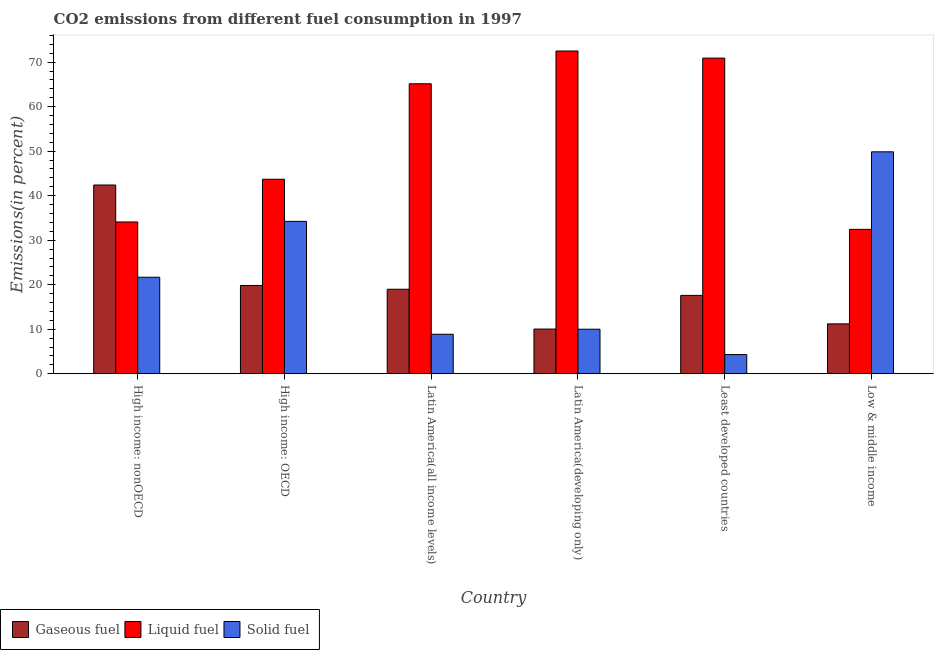How many groups of bars are there?
Provide a short and direct response. 6. How many bars are there on the 4th tick from the left?
Give a very brief answer. 3. What is the label of the 1st group of bars from the left?
Provide a short and direct response. High income: nonOECD. In how many cases, is the number of bars for a given country not equal to the number of legend labels?
Your response must be concise. 0. What is the percentage of gaseous fuel emission in Latin America(developing only)?
Your answer should be very brief. 10.04. Across all countries, what is the maximum percentage of solid fuel emission?
Provide a succinct answer. 49.85. Across all countries, what is the minimum percentage of liquid fuel emission?
Give a very brief answer. 32.44. What is the total percentage of gaseous fuel emission in the graph?
Give a very brief answer. 120.05. What is the difference between the percentage of solid fuel emission in High income: OECD and that in Latin America(developing only)?
Give a very brief answer. 24.23. What is the difference between the percentage of gaseous fuel emission in Latin America(all income levels) and the percentage of liquid fuel emission in Latin America(developing only)?
Your answer should be very brief. -53.52. What is the average percentage of liquid fuel emission per country?
Your answer should be compact. 53.13. What is the difference between the percentage of solid fuel emission and percentage of liquid fuel emission in Latin America(all income levels)?
Provide a succinct answer. -56.27. In how many countries, is the percentage of liquid fuel emission greater than 68 %?
Provide a succinct answer. 2. What is the ratio of the percentage of solid fuel emission in Latin America(all income levels) to that in Low & middle income?
Offer a very short reply. 0.18. Is the percentage of liquid fuel emission in High income: OECD less than that in Low & middle income?
Ensure brevity in your answer.  No. What is the difference between the highest and the second highest percentage of solid fuel emission?
Offer a terse response. 15.63. What is the difference between the highest and the lowest percentage of liquid fuel emission?
Your answer should be compact. 40.07. Is the sum of the percentage of solid fuel emission in High income: OECD and High income: nonOECD greater than the maximum percentage of liquid fuel emission across all countries?
Offer a very short reply. No. What does the 3rd bar from the left in Latin America(developing only) represents?
Ensure brevity in your answer.  Solid fuel. What does the 1st bar from the right in High income: nonOECD represents?
Keep it short and to the point. Solid fuel. Are all the bars in the graph horizontal?
Your response must be concise. No. What is the difference between two consecutive major ticks on the Y-axis?
Offer a terse response. 10. Are the values on the major ticks of Y-axis written in scientific E-notation?
Offer a terse response. No. Does the graph contain any zero values?
Offer a terse response. No. Does the graph contain grids?
Offer a very short reply. No. Where does the legend appear in the graph?
Give a very brief answer. Bottom left. What is the title of the graph?
Your answer should be compact. CO2 emissions from different fuel consumption in 1997. What is the label or title of the Y-axis?
Make the answer very short. Emissions(in percent). What is the Emissions(in percent) in Gaseous fuel in High income: nonOECD?
Make the answer very short. 42.4. What is the Emissions(in percent) in Liquid fuel in High income: nonOECD?
Make the answer very short. 34.1. What is the Emissions(in percent) in Solid fuel in High income: nonOECD?
Your answer should be compact. 21.68. What is the Emissions(in percent) in Gaseous fuel in High income: OECD?
Ensure brevity in your answer.  19.83. What is the Emissions(in percent) in Liquid fuel in High income: OECD?
Your response must be concise. 43.7. What is the Emissions(in percent) of Solid fuel in High income: OECD?
Your answer should be very brief. 34.23. What is the Emissions(in percent) in Gaseous fuel in Latin America(all income levels)?
Offer a terse response. 18.98. What is the Emissions(in percent) of Liquid fuel in Latin America(all income levels)?
Provide a succinct answer. 65.14. What is the Emissions(in percent) in Solid fuel in Latin America(all income levels)?
Offer a very short reply. 8.87. What is the Emissions(in percent) in Gaseous fuel in Latin America(developing only)?
Keep it short and to the point. 10.04. What is the Emissions(in percent) of Liquid fuel in Latin America(developing only)?
Your answer should be very brief. 72.5. What is the Emissions(in percent) of Solid fuel in Latin America(developing only)?
Your response must be concise. 10. What is the Emissions(in percent) of Gaseous fuel in Least developed countries?
Ensure brevity in your answer.  17.6. What is the Emissions(in percent) in Liquid fuel in Least developed countries?
Ensure brevity in your answer.  70.91. What is the Emissions(in percent) in Solid fuel in Least developed countries?
Provide a short and direct response. 4.31. What is the Emissions(in percent) in Gaseous fuel in Low & middle income?
Offer a very short reply. 11.2. What is the Emissions(in percent) in Liquid fuel in Low & middle income?
Make the answer very short. 32.44. What is the Emissions(in percent) of Solid fuel in Low & middle income?
Give a very brief answer. 49.85. Across all countries, what is the maximum Emissions(in percent) in Gaseous fuel?
Your answer should be compact. 42.4. Across all countries, what is the maximum Emissions(in percent) of Liquid fuel?
Give a very brief answer. 72.5. Across all countries, what is the maximum Emissions(in percent) in Solid fuel?
Keep it short and to the point. 49.85. Across all countries, what is the minimum Emissions(in percent) in Gaseous fuel?
Offer a terse response. 10.04. Across all countries, what is the minimum Emissions(in percent) in Liquid fuel?
Your response must be concise. 32.44. Across all countries, what is the minimum Emissions(in percent) of Solid fuel?
Give a very brief answer. 4.31. What is the total Emissions(in percent) in Gaseous fuel in the graph?
Your answer should be very brief. 120.05. What is the total Emissions(in percent) in Liquid fuel in the graph?
Offer a very short reply. 318.78. What is the total Emissions(in percent) in Solid fuel in the graph?
Ensure brevity in your answer.  128.95. What is the difference between the Emissions(in percent) in Gaseous fuel in High income: nonOECD and that in High income: OECD?
Provide a short and direct response. 22.57. What is the difference between the Emissions(in percent) of Liquid fuel in High income: nonOECD and that in High income: OECD?
Your answer should be very brief. -9.6. What is the difference between the Emissions(in percent) in Solid fuel in High income: nonOECD and that in High income: OECD?
Your answer should be compact. -12.55. What is the difference between the Emissions(in percent) in Gaseous fuel in High income: nonOECD and that in Latin America(all income levels)?
Your response must be concise. 23.42. What is the difference between the Emissions(in percent) in Liquid fuel in High income: nonOECD and that in Latin America(all income levels)?
Give a very brief answer. -31.05. What is the difference between the Emissions(in percent) of Solid fuel in High income: nonOECD and that in Latin America(all income levels)?
Keep it short and to the point. 12.81. What is the difference between the Emissions(in percent) of Gaseous fuel in High income: nonOECD and that in Latin America(developing only)?
Your answer should be compact. 32.36. What is the difference between the Emissions(in percent) of Liquid fuel in High income: nonOECD and that in Latin America(developing only)?
Make the answer very short. -38.41. What is the difference between the Emissions(in percent) of Solid fuel in High income: nonOECD and that in Latin America(developing only)?
Keep it short and to the point. 11.68. What is the difference between the Emissions(in percent) of Gaseous fuel in High income: nonOECD and that in Least developed countries?
Ensure brevity in your answer.  24.79. What is the difference between the Emissions(in percent) of Liquid fuel in High income: nonOECD and that in Least developed countries?
Ensure brevity in your answer.  -36.81. What is the difference between the Emissions(in percent) of Solid fuel in High income: nonOECD and that in Least developed countries?
Provide a succinct answer. 17.37. What is the difference between the Emissions(in percent) in Gaseous fuel in High income: nonOECD and that in Low & middle income?
Provide a succinct answer. 31.19. What is the difference between the Emissions(in percent) of Liquid fuel in High income: nonOECD and that in Low & middle income?
Provide a short and direct response. 1.66. What is the difference between the Emissions(in percent) in Solid fuel in High income: nonOECD and that in Low & middle income?
Ensure brevity in your answer.  -28.17. What is the difference between the Emissions(in percent) in Gaseous fuel in High income: OECD and that in Latin America(all income levels)?
Offer a very short reply. 0.85. What is the difference between the Emissions(in percent) in Liquid fuel in High income: OECD and that in Latin America(all income levels)?
Provide a succinct answer. -21.45. What is the difference between the Emissions(in percent) of Solid fuel in High income: OECD and that in Latin America(all income levels)?
Give a very brief answer. 25.36. What is the difference between the Emissions(in percent) of Gaseous fuel in High income: OECD and that in Latin America(developing only)?
Keep it short and to the point. 9.79. What is the difference between the Emissions(in percent) of Liquid fuel in High income: OECD and that in Latin America(developing only)?
Offer a terse response. -28.81. What is the difference between the Emissions(in percent) in Solid fuel in High income: OECD and that in Latin America(developing only)?
Offer a very short reply. 24.23. What is the difference between the Emissions(in percent) in Gaseous fuel in High income: OECD and that in Least developed countries?
Give a very brief answer. 2.23. What is the difference between the Emissions(in percent) in Liquid fuel in High income: OECD and that in Least developed countries?
Give a very brief answer. -27.21. What is the difference between the Emissions(in percent) of Solid fuel in High income: OECD and that in Least developed countries?
Your answer should be very brief. 29.92. What is the difference between the Emissions(in percent) in Gaseous fuel in High income: OECD and that in Low & middle income?
Offer a terse response. 8.63. What is the difference between the Emissions(in percent) of Liquid fuel in High income: OECD and that in Low & middle income?
Your answer should be very brief. 11.26. What is the difference between the Emissions(in percent) of Solid fuel in High income: OECD and that in Low & middle income?
Your answer should be very brief. -15.63. What is the difference between the Emissions(in percent) in Gaseous fuel in Latin America(all income levels) and that in Latin America(developing only)?
Give a very brief answer. 8.94. What is the difference between the Emissions(in percent) of Liquid fuel in Latin America(all income levels) and that in Latin America(developing only)?
Offer a terse response. -7.36. What is the difference between the Emissions(in percent) in Solid fuel in Latin America(all income levels) and that in Latin America(developing only)?
Your response must be concise. -1.13. What is the difference between the Emissions(in percent) in Gaseous fuel in Latin America(all income levels) and that in Least developed countries?
Your answer should be compact. 1.37. What is the difference between the Emissions(in percent) in Liquid fuel in Latin America(all income levels) and that in Least developed countries?
Give a very brief answer. -5.77. What is the difference between the Emissions(in percent) in Solid fuel in Latin America(all income levels) and that in Least developed countries?
Ensure brevity in your answer.  4.56. What is the difference between the Emissions(in percent) in Gaseous fuel in Latin America(all income levels) and that in Low & middle income?
Your answer should be compact. 7.77. What is the difference between the Emissions(in percent) in Liquid fuel in Latin America(all income levels) and that in Low & middle income?
Your answer should be compact. 32.71. What is the difference between the Emissions(in percent) in Solid fuel in Latin America(all income levels) and that in Low & middle income?
Provide a succinct answer. -40.99. What is the difference between the Emissions(in percent) of Gaseous fuel in Latin America(developing only) and that in Least developed countries?
Your answer should be very brief. -7.57. What is the difference between the Emissions(in percent) of Liquid fuel in Latin America(developing only) and that in Least developed countries?
Provide a succinct answer. 1.59. What is the difference between the Emissions(in percent) of Solid fuel in Latin America(developing only) and that in Least developed countries?
Keep it short and to the point. 5.69. What is the difference between the Emissions(in percent) of Gaseous fuel in Latin America(developing only) and that in Low & middle income?
Your answer should be very brief. -1.17. What is the difference between the Emissions(in percent) in Liquid fuel in Latin America(developing only) and that in Low & middle income?
Your response must be concise. 40.07. What is the difference between the Emissions(in percent) in Solid fuel in Latin America(developing only) and that in Low & middle income?
Ensure brevity in your answer.  -39.85. What is the difference between the Emissions(in percent) in Gaseous fuel in Least developed countries and that in Low & middle income?
Offer a terse response. 6.4. What is the difference between the Emissions(in percent) in Liquid fuel in Least developed countries and that in Low & middle income?
Provide a short and direct response. 38.47. What is the difference between the Emissions(in percent) of Solid fuel in Least developed countries and that in Low & middle income?
Keep it short and to the point. -45.54. What is the difference between the Emissions(in percent) of Gaseous fuel in High income: nonOECD and the Emissions(in percent) of Liquid fuel in High income: OECD?
Provide a succinct answer. -1.3. What is the difference between the Emissions(in percent) of Gaseous fuel in High income: nonOECD and the Emissions(in percent) of Solid fuel in High income: OECD?
Your answer should be very brief. 8.17. What is the difference between the Emissions(in percent) in Liquid fuel in High income: nonOECD and the Emissions(in percent) in Solid fuel in High income: OECD?
Ensure brevity in your answer.  -0.13. What is the difference between the Emissions(in percent) of Gaseous fuel in High income: nonOECD and the Emissions(in percent) of Liquid fuel in Latin America(all income levels)?
Your response must be concise. -22.74. What is the difference between the Emissions(in percent) of Gaseous fuel in High income: nonOECD and the Emissions(in percent) of Solid fuel in Latin America(all income levels)?
Keep it short and to the point. 33.53. What is the difference between the Emissions(in percent) in Liquid fuel in High income: nonOECD and the Emissions(in percent) in Solid fuel in Latin America(all income levels)?
Your answer should be compact. 25.23. What is the difference between the Emissions(in percent) of Gaseous fuel in High income: nonOECD and the Emissions(in percent) of Liquid fuel in Latin America(developing only)?
Provide a short and direct response. -30.1. What is the difference between the Emissions(in percent) of Gaseous fuel in High income: nonOECD and the Emissions(in percent) of Solid fuel in Latin America(developing only)?
Your answer should be very brief. 32.4. What is the difference between the Emissions(in percent) in Liquid fuel in High income: nonOECD and the Emissions(in percent) in Solid fuel in Latin America(developing only)?
Your answer should be compact. 24.09. What is the difference between the Emissions(in percent) in Gaseous fuel in High income: nonOECD and the Emissions(in percent) in Liquid fuel in Least developed countries?
Ensure brevity in your answer.  -28.51. What is the difference between the Emissions(in percent) of Gaseous fuel in High income: nonOECD and the Emissions(in percent) of Solid fuel in Least developed countries?
Give a very brief answer. 38.09. What is the difference between the Emissions(in percent) of Liquid fuel in High income: nonOECD and the Emissions(in percent) of Solid fuel in Least developed countries?
Your answer should be very brief. 29.79. What is the difference between the Emissions(in percent) of Gaseous fuel in High income: nonOECD and the Emissions(in percent) of Liquid fuel in Low & middle income?
Make the answer very short. 9.96. What is the difference between the Emissions(in percent) in Gaseous fuel in High income: nonOECD and the Emissions(in percent) in Solid fuel in Low & middle income?
Ensure brevity in your answer.  -7.46. What is the difference between the Emissions(in percent) in Liquid fuel in High income: nonOECD and the Emissions(in percent) in Solid fuel in Low & middle income?
Give a very brief answer. -15.76. What is the difference between the Emissions(in percent) of Gaseous fuel in High income: OECD and the Emissions(in percent) of Liquid fuel in Latin America(all income levels)?
Keep it short and to the point. -45.31. What is the difference between the Emissions(in percent) in Gaseous fuel in High income: OECD and the Emissions(in percent) in Solid fuel in Latin America(all income levels)?
Make the answer very short. 10.96. What is the difference between the Emissions(in percent) in Liquid fuel in High income: OECD and the Emissions(in percent) in Solid fuel in Latin America(all income levels)?
Provide a short and direct response. 34.83. What is the difference between the Emissions(in percent) in Gaseous fuel in High income: OECD and the Emissions(in percent) in Liquid fuel in Latin America(developing only)?
Provide a succinct answer. -52.67. What is the difference between the Emissions(in percent) of Gaseous fuel in High income: OECD and the Emissions(in percent) of Solid fuel in Latin America(developing only)?
Give a very brief answer. 9.83. What is the difference between the Emissions(in percent) of Liquid fuel in High income: OECD and the Emissions(in percent) of Solid fuel in Latin America(developing only)?
Your answer should be compact. 33.69. What is the difference between the Emissions(in percent) of Gaseous fuel in High income: OECD and the Emissions(in percent) of Liquid fuel in Least developed countries?
Offer a very short reply. -51.08. What is the difference between the Emissions(in percent) of Gaseous fuel in High income: OECD and the Emissions(in percent) of Solid fuel in Least developed countries?
Provide a short and direct response. 15.52. What is the difference between the Emissions(in percent) in Liquid fuel in High income: OECD and the Emissions(in percent) in Solid fuel in Least developed countries?
Offer a terse response. 39.38. What is the difference between the Emissions(in percent) of Gaseous fuel in High income: OECD and the Emissions(in percent) of Liquid fuel in Low & middle income?
Give a very brief answer. -12.61. What is the difference between the Emissions(in percent) in Gaseous fuel in High income: OECD and the Emissions(in percent) in Solid fuel in Low & middle income?
Ensure brevity in your answer.  -30.02. What is the difference between the Emissions(in percent) in Liquid fuel in High income: OECD and the Emissions(in percent) in Solid fuel in Low & middle income?
Ensure brevity in your answer.  -6.16. What is the difference between the Emissions(in percent) of Gaseous fuel in Latin America(all income levels) and the Emissions(in percent) of Liquid fuel in Latin America(developing only)?
Keep it short and to the point. -53.52. What is the difference between the Emissions(in percent) of Gaseous fuel in Latin America(all income levels) and the Emissions(in percent) of Solid fuel in Latin America(developing only)?
Offer a very short reply. 8.98. What is the difference between the Emissions(in percent) in Liquid fuel in Latin America(all income levels) and the Emissions(in percent) in Solid fuel in Latin America(developing only)?
Your answer should be very brief. 55.14. What is the difference between the Emissions(in percent) of Gaseous fuel in Latin America(all income levels) and the Emissions(in percent) of Liquid fuel in Least developed countries?
Give a very brief answer. -51.93. What is the difference between the Emissions(in percent) of Gaseous fuel in Latin America(all income levels) and the Emissions(in percent) of Solid fuel in Least developed countries?
Make the answer very short. 14.67. What is the difference between the Emissions(in percent) in Liquid fuel in Latin America(all income levels) and the Emissions(in percent) in Solid fuel in Least developed countries?
Your response must be concise. 60.83. What is the difference between the Emissions(in percent) in Gaseous fuel in Latin America(all income levels) and the Emissions(in percent) in Liquid fuel in Low & middle income?
Your answer should be compact. -13.46. What is the difference between the Emissions(in percent) in Gaseous fuel in Latin America(all income levels) and the Emissions(in percent) in Solid fuel in Low & middle income?
Provide a short and direct response. -30.88. What is the difference between the Emissions(in percent) in Liquid fuel in Latin America(all income levels) and the Emissions(in percent) in Solid fuel in Low & middle income?
Give a very brief answer. 15.29. What is the difference between the Emissions(in percent) of Gaseous fuel in Latin America(developing only) and the Emissions(in percent) of Liquid fuel in Least developed countries?
Provide a short and direct response. -60.87. What is the difference between the Emissions(in percent) of Gaseous fuel in Latin America(developing only) and the Emissions(in percent) of Solid fuel in Least developed countries?
Your answer should be compact. 5.73. What is the difference between the Emissions(in percent) of Liquid fuel in Latin America(developing only) and the Emissions(in percent) of Solid fuel in Least developed countries?
Offer a very short reply. 68.19. What is the difference between the Emissions(in percent) in Gaseous fuel in Latin America(developing only) and the Emissions(in percent) in Liquid fuel in Low & middle income?
Your answer should be compact. -22.4. What is the difference between the Emissions(in percent) in Gaseous fuel in Latin America(developing only) and the Emissions(in percent) in Solid fuel in Low & middle income?
Give a very brief answer. -39.82. What is the difference between the Emissions(in percent) in Liquid fuel in Latin America(developing only) and the Emissions(in percent) in Solid fuel in Low & middle income?
Provide a succinct answer. 22.65. What is the difference between the Emissions(in percent) of Gaseous fuel in Least developed countries and the Emissions(in percent) of Liquid fuel in Low & middle income?
Provide a succinct answer. -14.83. What is the difference between the Emissions(in percent) in Gaseous fuel in Least developed countries and the Emissions(in percent) in Solid fuel in Low & middle income?
Your answer should be compact. -32.25. What is the difference between the Emissions(in percent) of Liquid fuel in Least developed countries and the Emissions(in percent) of Solid fuel in Low & middle income?
Ensure brevity in your answer.  21.06. What is the average Emissions(in percent) of Gaseous fuel per country?
Provide a short and direct response. 20.01. What is the average Emissions(in percent) in Liquid fuel per country?
Your response must be concise. 53.13. What is the average Emissions(in percent) in Solid fuel per country?
Keep it short and to the point. 21.49. What is the difference between the Emissions(in percent) of Gaseous fuel and Emissions(in percent) of Liquid fuel in High income: nonOECD?
Your answer should be very brief. 8.3. What is the difference between the Emissions(in percent) of Gaseous fuel and Emissions(in percent) of Solid fuel in High income: nonOECD?
Make the answer very short. 20.72. What is the difference between the Emissions(in percent) of Liquid fuel and Emissions(in percent) of Solid fuel in High income: nonOECD?
Make the answer very short. 12.41. What is the difference between the Emissions(in percent) of Gaseous fuel and Emissions(in percent) of Liquid fuel in High income: OECD?
Offer a terse response. -23.87. What is the difference between the Emissions(in percent) of Gaseous fuel and Emissions(in percent) of Solid fuel in High income: OECD?
Offer a very short reply. -14.4. What is the difference between the Emissions(in percent) of Liquid fuel and Emissions(in percent) of Solid fuel in High income: OECD?
Provide a succinct answer. 9.47. What is the difference between the Emissions(in percent) in Gaseous fuel and Emissions(in percent) in Liquid fuel in Latin America(all income levels)?
Offer a very short reply. -46.16. What is the difference between the Emissions(in percent) in Gaseous fuel and Emissions(in percent) in Solid fuel in Latin America(all income levels)?
Ensure brevity in your answer.  10.11. What is the difference between the Emissions(in percent) of Liquid fuel and Emissions(in percent) of Solid fuel in Latin America(all income levels)?
Offer a terse response. 56.27. What is the difference between the Emissions(in percent) in Gaseous fuel and Emissions(in percent) in Liquid fuel in Latin America(developing only)?
Provide a succinct answer. -62.46. What is the difference between the Emissions(in percent) in Gaseous fuel and Emissions(in percent) in Solid fuel in Latin America(developing only)?
Make the answer very short. 0.04. What is the difference between the Emissions(in percent) of Liquid fuel and Emissions(in percent) of Solid fuel in Latin America(developing only)?
Your answer should be very brief. 62.5. What is the difference between the Emissions(in percent) of Gaseous fuel and Emissions(in percent) of Liquid fuel in Least developed countries?
Keep it short and to the point. -53.31. What is the difference between the Emissions(in percent) in Gaseous fuel and Emissions(in percent) in Solid fuel in Least developed countries?
Keep it short and to the point. 13.29. What is the difference between the Emissions(in percent) of Liquid fuel and Emissions(in percent) of Solid fuel in Least developed countries?
Keep it short and to the point. 66.6. What is the difference between the Emissions(in percent) in Gaseous fuel and Emissions(in percent) in Liquid fuel in Low & middle income?
Your answer should be very brief. -21.23. What is the difference between the Emissions(in percent) in Gaseous fuel and Emissions(in percent) in Solid fuel in Low & middle income?
Provide a succinct answer. -38.65. What is the difference between the Emissions(in percent) of Liquid fuel and Emissions(in percent) of Solid fuel in Low & middle income?
Your answer should be compact. -17.42. What is the ratio of the Emissions(in percent) in Gaseous fuel in High income: nonOECD to that in High income: OECD?
Provide a succinct answer. 2.14. What is the ratio of the Emissions(in percent) in Liquid fuel in High income: nonOECD to that in High income: OECD?
Offer a very short reply. 0.78. What is the ratio of the Emissions(in percent) in Solid fuel in High income: nonOECD to that in High income: OECD?
Offer a terse response. 0.63. What is the ratio of the Emissions(in percent) in Gaseous fuel in High income: nonOECD to that in Latin America(all income levels)?
Offer a very short reply. 2.23. What is the ratio of the Emissions(in percent) in Liquid fuel in High income: nonOECD to that in Latin America(all income levels)?
Your answer should be very brief. 0.52. What is the ratio of the Emissions(in percent) in Solid fuel in High income: nonOECD to that in Latin America(all income levels)?
Your response must be concise. 2.44. What is the ratio of the Emissions(in percent) in Gaseous fuel in High income: nonOECD to that in Latin America(developing only)?
Keep it short and to the point. 4.22. What is the ratio of the Emissions(in percent) of Liquid fuel in High income: nonOECD to that in Latin America(developing only)?
Keep it short and to the point. 0.47. What is the ratio of the Emissions(in percent) in Solid fuel in High income: nonOECD to that in Latin America(developing only)?
Offer a terse response. 2.17. What is the ratio of the Emissions(in percent) of Gaseous fuel in High income: nonOECD to that in Least developed countries?
Provide a succinct answer. 2.41. What is the ratio of the Emissions(in percent) of Liquid fuel in High income: nonOECD to that in Least developed countries?
Make the answer very short. 0.48. What is the ratio of the Emissions(in percent) of Solid fuel in High income: nonOECD to that in Least developed countries?
Make the answer very short. 5.03. What is the ratio of the Emissions(in percent) of Gaseous fuel in High income: nonOECD to that in Low & middle income?
Your answer should be compact. 3.78. What is the ratio of the Emissions(in percent) in Liquid fuel in High income: nonOECD to that in Low & middle income?
Your response must be concise. 1.05. What is the ratio of the Emissions(in percent) in Solid fuel in High income: nonOECD to that in Low & middle income?
Make the answer very short. 0.43. What is the ratio of the Emissions(in percent) of Gaseous fuel in High income: OECD to that in Latin America(all income levels)?
Your answer should be compact. 1.04. What is the ratio of the Emissions(in percent) in Liquid fuel in High income: OECD to that in Latin America(all income levels)?
Offer a very short reply. 0.67. What is the ratio of the Emissions(in percent) in Solid fuel in High income: OECD to that in Latin America(all income levels)?
Give a very brief answer. 3.86. What is the ratio of the Emissions(in percent) in Gaseous fuel in High income: OECD to that in Latin America(developing only)?
Make the answer very short. 1.98. What is the ratio of the Emissions(in percent) in Liquid fuel in High income: OECD to that in Latin America(developing only)?
Your response must be concise. 0.6. What is the ratio of the Emissions(in percent) of Solid fuel in High income: OECD to that in Latin America(developing only)?
Offer a very short reply. 3.42. What is the ratio of the Emissions(in percent) of Gaseous fuel in High income: OECD to that in Least developed countries?
Give a very brief answer. 1.13. What is the ratio of the Emissions(in percent) of Liquid fuel in High income: OECD to that in Least developed countries?
Keep it short and to the point. 0.62. What is the ratio of the Emissions(in percent) in Solid fuel in High income: OECD to that in Least developed countries?
Make the answer very short. 7.94. What is the ratio of the Emissions(in percent) of Gaseous fuel in High income: OECD to that in Low & middle income?
Provide a succinct answer. 1.77. What is the ratio of the Emissions(in percent) of Liquid fuel in High income: OECD to that in Low & middle income?
Your response must be concise. 1.35. What is the ratio of the Emissions(in percent) of Solid fuel in High income: OECD to that in Low & middle income?
Offer a terse response. 0.69. What is the ratio of the Emissions(in percent) in Gaseous fuel in Latin America(all income levels) to that in Latin America(developing only)?
Keep it short and to the point. 1.89. What is the ratio of the Emissions(in percent) in Liquid fuel in Latin America(all income levels) to that in Latin America(developing only)?
Your answer should be compact. 0.9. What is the ratio of the Emissions(in percent) in Solid fuel in Latin America(all income levels) to that in Latin America(developing only)?
Provide a succinct answer. 0.89. What is the ratio of the Emissions(in percent) of Gaseous fuel in Latin America(all income levels) to that in Least developed countries?
Offer a very short reply. 1.08. What is the ratio of the Emissions(in percent) of Liquid fuel in Latin America(all income levels) to that in Least developed countries?
Your answer should be compact. 0.92. What is the ratio of the Emissions(in percent) of Solid fuel in Latin America(all income levels) to that in Least developed countries?
Your response must be concise. 2.06. What is the ratio of the Emissions(in percent) in Gaseous fuel in Latin America(all income levels) to that in Low & middle income?
Make the answer very short. 1.69. What is the ratio of the Emissions(in percent) of Liquid fuel in Latin America(all income levels) to that in Low & middle income?
Your answer should be compact. 2.01. What is the ratio of the Emissions(in percent) of Solid fuel in Latin America(all income levels) to that in Low & middle income?
Ensure brevity in your answer.  0.18. What is the ratio of the Emissions(in percent) in Gaseous fuel in Latin America(developing only) to that in Least developed countries?
Provide a short and direct response. 0.57. What is the ratio of the Emissions(in percent) of Liquid fuel in Latin America(developing only) to that in Least developed countries?
Your answer should be very brief. 1.02. What is the ratio of the Emissions(in percent) in Solid fuel in Latin America(developing only) to that in Least developed countries?
Your answer should be compact. 2.32. What is the ratio of the Emissions(in percent) of Gaseous fuel in Latin America(developing only) to that in Low & middle income?
Offer a very short reply. 0.9. What is the ratio of the Emissions(in percent) of Liquid fuel in Latin America(developing only) to that in Low & middle income?
Make the answer very short. 2.24. What is the ratio of the Emissions(in percent) of Solid fuel in Latin America(developing only) to that in Low & middle income?
Offer a very short reply. 0.2. What is the ratio of the Emissions(in percent) in Gaseous fuel in Least developed countries to that in Low & middle income?
Your answer should be very brief. 1.57. What is the ratio of the Emissions(in percent) in Liquid fuel in Least developed countries to that in Low & middle income?
Make the answer very short. 2.19. What is the ratio of the Emissions(in percent) in Solid fuel in Least developed countries to that in Low & middle income?
Ensure brevity in your answer.  0.09. What is the difference between the highest and the second highest Emissions(in percent) in Gaseous fuel?
Give a very brief answer. 22.57. What is the difference between the highest and the second highest Emissions(in percent) of Liquid fuel?
Offer a terse response. 1.59. What is the difference between the highest and the second highest Emissions(in percent) in Solid fuel?
Provide a succinct answer. 15.63. What is the difference between the highest and the lowest Emissions(in percent) in Gaseous fuel?
Your answer should be very brief. 32.36. What is the difference between the highest and the lowest Emissions(in percent) in Liquid fuel?
Your answer should be compact. 40.07. What is the difference between the highest and the lowest Emissions(in percent) in Solid fuel?
Offer a very short reply. 45.54. 